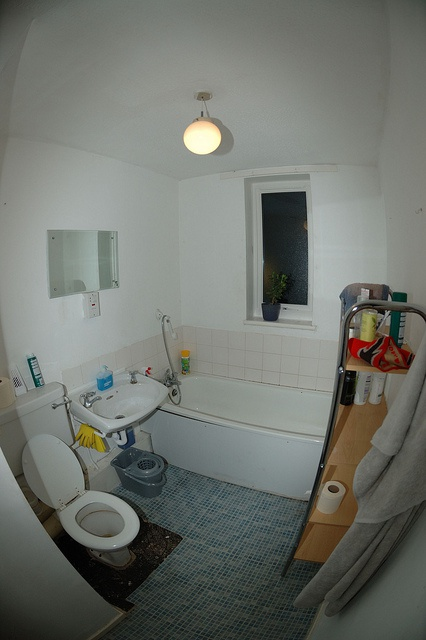Describe the objects in this image and their specific colors. I can see toilet in black and gray tones, sink in black, darkgray, and gray tones, and potted plant in black, gray, and darkgreen tones in this image. 